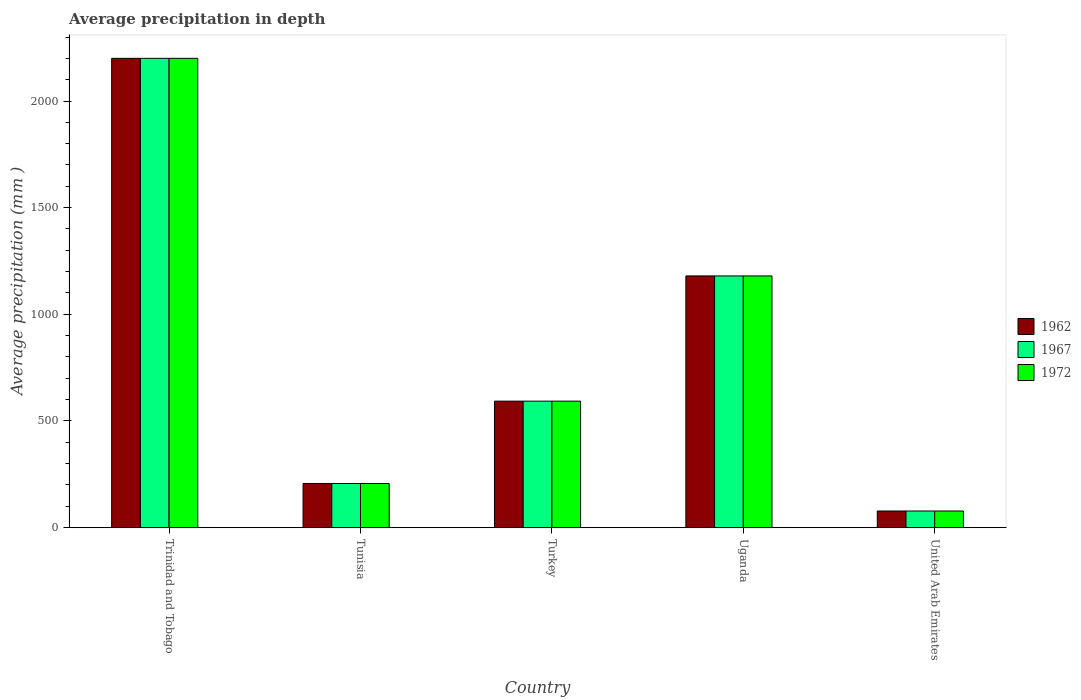Are the number of bars per tick equal to the number of legend labels?
Keep it short and to the point. Yes. Are the number of bars on each tick of the X-axis equal?
Provide a succinct answer. Yes. How many bars are there on the 5th tick from the left?
Make the answer very short. 3. What is the label of the 3rd group of bars from the left?
Your response must be concise. Turkey. What is the average precipitation in 1972 in United Arab Emirates?
Provide a succinct answer. 78. Across all countries, what is the maximum average precipitation in 1962?
Give a very brief answer. 2200. In which country was the average precipitation in 1962 maximum?
Ensure brevity in your answer.  Trinidad and Tobago. In which country was the average precipitation in 1962 minimum?
Offer a terse response. United Arab Emirates. What is the total average precipitation in 1967 in the graph?
Offer a very short reply. 4258. What is the difference between the average precipitation in 1967 in Trinidad and Tobago and that in United Arab Emirates?
Keep it short and to the point. 2122. What is the difference between the average precipitation in 1972 in United Arab Emirates and the average precipitation in 1962 in Uganda?
Your response must be concise. -1102. What is the average average precipitation in 1962 per country?
Your answer should be compact. 851.6. What is the difference between the average precipitation of/in 1962 and average precipitation of/in 1972 in Uganda?
Provide a short and direct response. 0. What is the ratio of the average precipitation in 1972 in Tunisia to that in Turkey?
Give a very brief answer. 0.35. Is the average precipitation in 1967 in Tunisia less than that in United Arab Emirates?
Keep it short and to the point. No. What is the difference between the highest and the second highest average precipitation in 1967?
Provide a succinct answer. 1607. What is the difference between the highest and the lowest average precipitation in 1962?
Your answer should be compact. 2122. In how many countries, is the average precipitation in 1972 greater than the average average precipitation in 1972 taken over all countries?
Ensure brevity in your answer.  2. What does the 3rd bar from the left in Tunisia represents?
Keep it short and to the point. 1972. What does the 2nd bar from the right in United Arab Emirates represents?
Your response must be concise. 1967. Is it the case that in every country, the sum of the average precipitation in 1967 and average precipitation in 1972 is greater than the average precipitation in 1962?
Ensure brevity in your answer.  Yes. Are all the bars in the graph horizontal?
Offer a terse response. No. How many countries are there in the graph?
Make the answer very short. 5. What is the difference between two consecutive major ticks on the Y-axis?
Your answer should be compact. 500. Are the values on the major ticks of Y-axis written in scientific E-notation?
Make the answer very short. No. Does the graph contain any zero values?
Make the answer very short. No. What is the title of the graph?
Offer a terse response. Average precipitation in depth. Does "1962" appear as one of the legend labels in the graph?
Ensure brevity in your answer.  Yes. What is the label or title of the Y-axis?
Provide a succinct answer. Average precipitation (mm ). What is the Average precipitation (mm ) in 1962 in Trinidad and Tobago?
Offer a very short reply. 2200. What is the Average precipitation (mm ) in 1967 in Trinidad and Tobago?
Keep it short and to the point. 2200. What is the Average precipitation (mm ) of 1972 in Trinidad and Tobago?
Offer a terse response. 2200. What is the Average precipitation (mm ) in 1962 in Tunisia?
Make the answer very short. 207. What is the Average precipitation (mm ) of 1967 in Tunisia?
Make the answer very short. 207. What is the Average precipitation (mm ) of 1972 in Tunisia?
Ensure brevity in your answer.  207. What is the Average precipitation (mm ) of 1962 in Turkey?
Give a very brief answer. 593. What is the Average precipitation (mm ) in 1967 in Turkey?
Offer a terse response. 593. What is the Average precipitation (mm ) of 1972 in Turkey?
Give a very brief answer. 593. What is the Average precipitation (mm ) of 1962 in Uganda?
Your response must be concise. 1180. What is the Average precipitation (mm ) of 1967 in Uganda?
Your answer should be compact. 1180. What is the Average precipitation (mm ) in 1972 in Uganda?
Make the answer very short. 1180. What is the Average precipitation (mm ) in 1962 in United Arab Emirates?
Make the answer very short. 78. What is the Average precipitation (mm ) of 1967 in United Arab Emirates?
Make the answer very short. 78. What is the Average precipitation (mm ) of 1972 in United Arab Emirates?
Your answer should be compact. 78. Across all countries, what is the maximum Average precipitation (mm ) in 1962?
Offer a very short reply. 2200. Across all countries, what is the maximum Average precipitation (mm ) of 1967?
Your answer should be very brief. 2200. Across all countries, what is the maximum Average precipitation (mm ) of 1972?
Give a very brief answer. 2200. Across all countries, what is the minimum Average precipitation (mm ) in 1972?
Make the answer very short. 78. What is the total Average precipitation (mm ) in 1962 in the graph?
Ensure brevity in your answer.  4258. What is the total Average precipitation (mm ) of 1967 in the graph?
Offer a very short reply. 4258. What is the total Average precipitation (mm ) of 1972 in the graph?
Ensure brevity in your answer.  4258. What is the difference between the Average precipitation (mm ) of 1962 in Trinidad and Tobago and that in Tunisia?
Your response must be concise. 1993. What is the difference between the Average precipitation (mm ) in 1967 in Trinidad and Tobago and that in Tunisia?
Your answer should be very brief. 1993. What is the difference between the Average precipitation (mm ) in 1972 in Trinidad and Tobago and that in Tunisia?
Your response must be concise. 1993. What is the difference between the Average precipitation (mm ) in 1962 in Trinidad and Tobago and that in Turkey?
Your response must be concise. 1607. What is the difference between the Average precipitation (mm ) in 1967 in Trinidad and Tobago and that in Turkey?
Make the answer very short. 1607. What is the difference between the Average precipitation (mm ) in 1972 in Trinidad and Tobago and that in Turkey?
Provide a short and direct response. 1607. What is the difference between the Average precipitation (mm ) of 1962 in Trinidad and Tobago and that in Uganda?
Ensure brevity in your answer.  1020. What is the difference between the Average precipitation (mm ) of 1967 in Trinidad and Tobago and that in Uganda?
Offer a terse response. 1020. What is the difference between the Average precipitation (mm ) of 1972 in Trinidad and Tobago and that in Uganda?
Your answer should be very brief. 1020. What is the difference between the Average precipitation (mm ) in 1962 in Trinidad and Tobago and that in United Arab Emirates?
Ensure brevity in your answer.  2122. What is the difference between the Average precipitation (mm ) of 1967 in Trinidad and Tobago and that in United Arab Emirates?
Provide a succinct answer. 2122. What is the difference between the Average precipitation (mm ) in 1972 in Trinidad and Tobago and that in United Arab Emirates?
Provide a short and direct response. 2122. What is the difference between the Average precipitation (mm ) in 1962 in Tunisia and that in Turkey?
Your response must be concise. -386. What is the difference between the Average precipitation (mm ) of 1967 in Tunisia and that in Turkey?
Provide a short and direct response. -386. What is the difference between the Average precipitation (mm ) of 1972 in Tunisia and that in Turkey?
Make the answer very short. -386. What is the difference between the Average precipitation (mm ) in 1962 in Tunisia and that in Uganda?
Ensure brevity in your answer.  -973. What is the difference between the Average precipitation (mm ) of 1967 in Tunisia and that in Uganda?
Offer a very short reply. -973. What is the difference between the Average precipitation (mm ) of 1972 in Tunisia and that in Uganda?
Provide a succinct answer. -973. What is the difference between the Average precipitation (mm ) of 1962 in Tunisia and that in United Arab Emirates?
Make the answer very short. 129. What is the difference between the Average precipitation (mm ) of 1967 in Tunisia and that in United Arab Emirates?
Keep it short and to the point. 129. What is the difference between the Average precipitation (mm ) in 1972 in Tunisia and that in United Arab Emirates?
Your answer should be compact. 129. What is the difference between the Average precipitation (mm ) of 1962 in Turkey and that in Uganda?
Offer a terse response. -587. What is the difference between the Average precipitation (mm ) of 1967 in Turkey and that in Uganda?
Offer a terse response. -587. What is the difference between the Average precipitation (mm ) in 1972 in Turkey and that in Uganda?
Provide a succinct answer. -587. What is the difference between the Average precipitation (mm ) of 1962 in Turkey and that in United Arab Emirates?
Your response must be concise. 515. What is the difference between the Average precipitation (mm ) of 1967 in Turkey and that in United Arab Emirates?
Keep it short and to the point. 515. What is the difference between the Average precipitation (mm ) in 1972 in Turkey and that in United Arab Emirates?
Offer a very short reply. 515. What is the difference between the Average precipitation (mm ) of 1962 in Uganda and that in United Arab Emirates?
Give a very brief answer. 1102. What is the difference between the Average precipitation (mm ) of 1967 in Uganda and that in United Arab Emirates?
Your answer should be compact. 1102. What is the difference between the Average precipitation (mm ) in 1972 in Uganda and that in United Arab Emirates?
Your response must be concise. 1102. What is the difference between the Average precipitation (mm ) in 1962 in Trinidad and Tobago and the Average precipitation (mm ) in 1967 in Tunisia?
Offer a very short reply. 1993. What is the difference between the Average precipitation (mm ) in 1962 in Trinidad and Tobago and the Average precipitation (mm ) in 1972 in Tunisia?
Ensure brevity in your answer.  1993. What is the difference between the Average precipitation (mm ) in 1967 in Trinidad and Tobago and the Average precipitation (mm ) in 1972 in Tunisia?
Keep it short and to the point. 1993. What is the difference between the Average precipitation (mm ) in 1962 in Trinidad and Tobago and the Average precipitation (mm ) in 1967 in Turkey?
Your answer should be very brief. 1607. What is the difference between the Average precipitation (mm ) in 1962 in Trinidad and Tobago and the Average precipitation (mm ) in 1972 in Turkey?
Keep it short and to the point. 1607. What is the difference between the Average precipitation (mm ) in 1967 in Trinidad and Tobago and the Average precipitation (mm ) in 1972 in Turkey?
Provide a succinct answer. 1607. What is the difference between the Average precipitation (mm ) in 1962 in Trinidad and Tobago and the Average precipitation (mm ) in 1967 in Uganda?
Your answer should be very brief. 1020. What is the difference between the Average precipitation (mm ) of 1962 in Trinidad and Tobago and the Average precipitation (mm ) of 1972 in Uganda?
Your answer should be very brief. 1020. What is the difference between the Average precipitation (mm ) in 1967 in Trinidad and Tobago and the Average precipitation (mm ) in 1972 in Uganda?
Give a very brief answer. 1020. What is the difference between the Average precipitation (mm ) of 1962 in Trinidad and Tobago and the Average precipitation (mm ) of 1967 in United Arab Emirates?
Ensure brevity in your answer.  2122. What is the difference between the Average precipitation (mm ) of 1962 in Trinidad and Tobago and the Average precipitation (mm ) of 1972 in United Arab Emirates?
Ensure brevity in your answer.  2122. What is the difference between the Average precipitation (mm ) of 1967 in Trinidad and Tobago and the Average precipitation (mm ) of 1972 in United Arab Emirates?
Your answer should be very brief. 2122. What is the difference between the Average precipitation (mm ) of 1962 in Tunisia and the Average precipitation (mm ) of 1967 in Turkey?
Offer a very short reply. -386. What is the difference between the Average precipitation (mm ) of 1962 in Tunisia and the Average precipitation (mm ) of 1972 in Turkey?
Offer a terse response. -386. What is the difference between the Average precipitation (mm ) of 1967 in Tunisia and the Average precipitation (mm ) of 1972 in Turkey?
Provide a succinct answer. -386. What is the difference between the Average precipitation (mm ) in 1962 in Tunisia and the Average precipitation (mm ) in 1967 in Uganda?
Your answer should be very brief. -973. What is the difference between the Average precipitation (mm ) of 1962 in Tunisia and the Average precipitation (mm ) of 1972 in Uganda?
Make the answer very short. -973. What is the difference between the Average precipitation (mm ) in 1967 in Tunisia and the Average precipitation (mm ) in 1972 in Uganda?
Your response must be concise. -973. What is the difference between the Average precipitation (mm ) in 1962 in Tunisia and the Average precipitation (mm ) in 1967 in United Arab Emirates?
Offer a very short reply. 129. What is the difference between the Average precipitation (mm ) of 1962 in Tunisia and the Average precipitation (mm ) of 1972 in United Arab Emirates?
Your answer should be compact. 129. What is the difference between the Average precipitation (mm ) of 1967 in Tunisia and the Average precipitation (mm ) of 1972 in United Arab Emirates?
Offer a very short reply. 129. What is the difference between the Average precipitation (mm ) in 1962 in Turkey and the Average precipitation (mm ) in 1967 in Uganda?
Ensure brevity in your answer.  -587. What is the difference between the Average precipitation (mm ) in 1962 in Turkey and the Average precipitation (mm ) in 1972 in Uganda?
Make the answer very short. -587. What is the difference between the Average precipitation (mm ) of 1967 in Turkey and the Average precipitation (mm ) of 1972 in Uganda?
Keep it short and to the point. -587. What is the difference between the Average precipitation (mm ) of 1962 in Turkey and the Average precipitation (mm ) of 1967 in United Arab Emirates?
Make the answer very short. 515. What is the difference between the Average precipitation (mm ) in 1962 in Turkey and the Average precipitation (mm ) in 1972 in United Arab Emirates?
Keep it short and to the point. 515. What is the difference between the Average precipitation (mm ) in 1967 in Turkey and the Average precipitation (mm ) in 1972 in United Arab Emirates?
Make the answer very short. 515. What is the difference between the Average precipitation (mm ) of 1962 in Uganda and the Average precipitation (mm ) of 1967 in United Arab Emirates?
Offer a terse response. 1102. What is the difference between the Average precipitation (mm ) in 1962 in Uganda and the Average precipitation (mm ) in 1972 in United Arab Emirates?
Your response must be concise. 1102. What is the difference between the Average precipitation (mm ) of 1967 in Uganda and the Average precipitation (mm ) of 1972 in United Arab Emirates?
Provide a succinct answer. 1102. What is the average Average precipitation (mm ) in 1962 per country?
Your answer should be compact. 851.6. What is the average Average precipitation (mm ) in 1967 per country?
Your answer should be compact. 851.6. What is the average Average precipitation (mm ) of 1972 per country?
Ensure brevity in your answer.  851.6. What is the difference between the Average precipitation (mm ) in 1967 and Average precipitation (mm ) in 1972 in Trinidad and Tobago?
Your response must be concise. 0. What is the difference between the Average precipitation (mm ) of 1962 and Average precipitation (mm ) of 1967 in Tunisia?
Provide a short and direct response. 0. What is the difference between the Average precipitation (mm ) of 1967 and Average precipitation (mm ) of 1972 in Turkey?
Offer a very short reply. 0. What is the difference between the Average precipitation (mm ) of 1962 and Average precipitation (mm ) of 1972 in Uganda?
Ensure brevity in your answer.  0. What is the difference between the Average precipitation (mm ) of 1967 and Average precipitation (mm ) of 1972 in Uganda?
Your answer should be compact. 0. What is the difference between the Average precipitation (mm ) of 1962 and Average precipitation (mm ) of 1967 in United Arab Emirates?
Make the answer very short. 0. What is the difference between the Average precipitation (mm ) in 1967 and Average precipitation (mm ) in 1972 in United Arab Emirates?
Make the answer very short. 0. What is the ratio of the Average precipitation (mm ) in 1962 in Trinidad and Tobago to that in Tunisia?
Ensure brevity in your answer.  10.63. What is the ratio of the Average precipitation (mm ) in 1967 in Trinidad and Tobago to that in Tunisia?
Offer a very short reply. 10.63. What is the ratio of the Average precipitation (mm ) in 1972 in Trinidad and Tobago to that in Tunisia?
Provide a succinct answer. 10.63. What is the ratio of the Average precipitation (mm ) in 1962 in Trinidad and Tobago to that in Turkey?
Provide a short and direct response. 3.71. What is the ratio of the Average precipitation (mm ) in 1967 in Trinidad and Tobago to that in Turkey?
Ensure brevity in your answer.  3.71. What is the ratio of the Average precipitation (mm ) of 1972 in Trinidad and Tobago to that in Turkey?
Provide a succinct answer. 3.71. What is the ratio of the Average precipitation (mm ) of 1962 in Trinidad and Tobago to that in Uganda?
Offer a terse response. 1.86. What is the ratio of the Average precipitation (mm ) in 1967 in Trinidad and Tobago to that in Uganda?
Keep it short and to the point. 1.86. What is the ratio of the Average precipitation (mm ) of 1972 in Trinidad and Tobago to that in Uganda?
Your response must be concise. 1.86. What is the ratio of the Average precipitation (mm ) of 1962 in Trinidad and Tobago to that in United Arab Emirates?
Offer a terse response. 28.21. What is the ratio of the Average precipitation (mm ) in 1967 in Trinidad and Tobago to that in United Arab Emirates?
Offer a terse response. 28.21. What is the ratio of the Average precipitation (mm ) in 1972 in Trinidad and Tobago to that in United Arab Emirates?
Provide a succinct answer. 28.21. What is the ratio of the Average precipitation (mm ) of 1962 in Tunisia to that in Turkey?
Ensure brevity in your answer.  0.35. What is the ratio of the Average precipitation (mm ) in 1967 in Tunisia to that in Turkey?
Offer a terse response. 0.35. What is the ratio of the Average precipitation (mm ) of 1972 in Tunisia to that in Turkey?
Give a very brief answer. 0.35. What is the ratio of the Average precipitation (mm ) of 1962 in Tunisia to that in Uganda?
Provide a short and direct response. 0.18. What is the ratio of the Average precipitation (mm ) in 1967 in Tunisia to that in Uganda?
Give a very brief answer. 0.18. What is the ratio of the Average precipitation (mm ) of 1972 in Tunisia to that in Uganda?
Offer a terse response. 0.18. What is the ratio of the Average precipitation (mm ) in 1962 in Tunisia to that in United Arab Emirates?
Offer a terse response. 2.65. What is the ratio of the Average precipitation (mm ) in 1967 in Tunisia to that in United Arab Emirates?
Offer a terse response. 2.65. What is the ratio of the Average precipitation (mm ) of 1972 in Tunisia to that in United Arab Emirates?
Give a very brief answer. 2.65. What is the ratio of the Average precipitation (mm ) in 1962 in Turkey to that in Uganda?
Provide a succinct answer. 0.5. What is the ratio of the Average precipitation (mm ) of 1967 in Turkey to that in Uganda?
Provide a short and direct response. 0.5. What is the ratio of the Average precipitation (mm ) in 1972 in Turkey to that in Uganda?
Give a very brief answer. 0.5. What is the ratio of the Average precipitation (mm ) in 1962 in Turkey to that in United Arab Emirates?
Offer a very short reply. 7.6. What is the ratio of the Average precipitation (mm ) of 1967 in Turkey to that in United Arab Emirates?
Your response must be concise. 7.6. What is the ratio of the Average precipitation (mm ) of 1972 in Turkey to that in United Arab Emirates?
Your answer should be compact. 7.6. What is the ratio of the Average precipitation (mm ) of 1962 in Uganda to that in United Arab Emirates?
Provide a short and direct response. 15.13. What is the ratio of the Average precipitation (mm ) of 1967 in Uganda to that in United Arab Emirates?
Give a very brief answer. 15.13. What is the ratio of the Average precipitation (mm ) in 1972 in Uganda to that in United Arab Emirates?
Ensure brevity in your answer.  15.13. What is the difference between the highest and the second highest Average precipitation (mm ) in 1962?
Give a very brief answer. 1020. What is the difference between the highest and the second highest Average precipitation (mm ) of 1967?
Provide a short and direct response. 1020. What is the difference between the highest and the second highest Average precipitation (mm ) in 1972?
Your answer should be very brief. 1020. What is the difference between the highest and the lowest Average precipitation (mm ) in 1962?
Provide a succinct answer. 2122. What is the difference between the highest and the lowest Average precipitation (mm ) of 1967?
Offer a terse response. 2122. What is the difference between the highest and the lowest Average precipitation (mm ) in 1972?
Your response must be concise. 2122. 